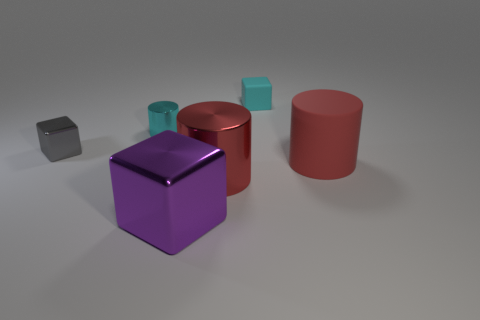Are there any large metallic cylinders of the same color as the big matte object?
Keep it short and to the point. Yes. There is a thing that is the same color as the small cylinder; what is its shape?
Your response must be concise. Cube. What material is the small cyan cube?
Provide a short and direct response. Rubber. The large block is what color?
Your answer should be compact. Purple. There is a cylinder that is on the right side of the big purple cube and on the left side of the rubber cube; what color is it?
Ensure brevity in your answer.  Red. Is there anything else that is made of the same material as the gray thing?
Your response must be concise. Yes. Is the large block made of the same material as the cylinder that is behind the small gray block?
Make the answer very short. Yes. There is a metal cylinder right of the cube in front of the matte cylinder; how big is it?
Keep it short and to the point. Large. Is there any other thing that has the same color as the matte cylinder?
Provide a short and direct response. Yes. Does the red thing on the right side of the red shiny cylinder have the same material as the cube that is in front of the tiny gray metal thing?
Offer a very short reply. No. 